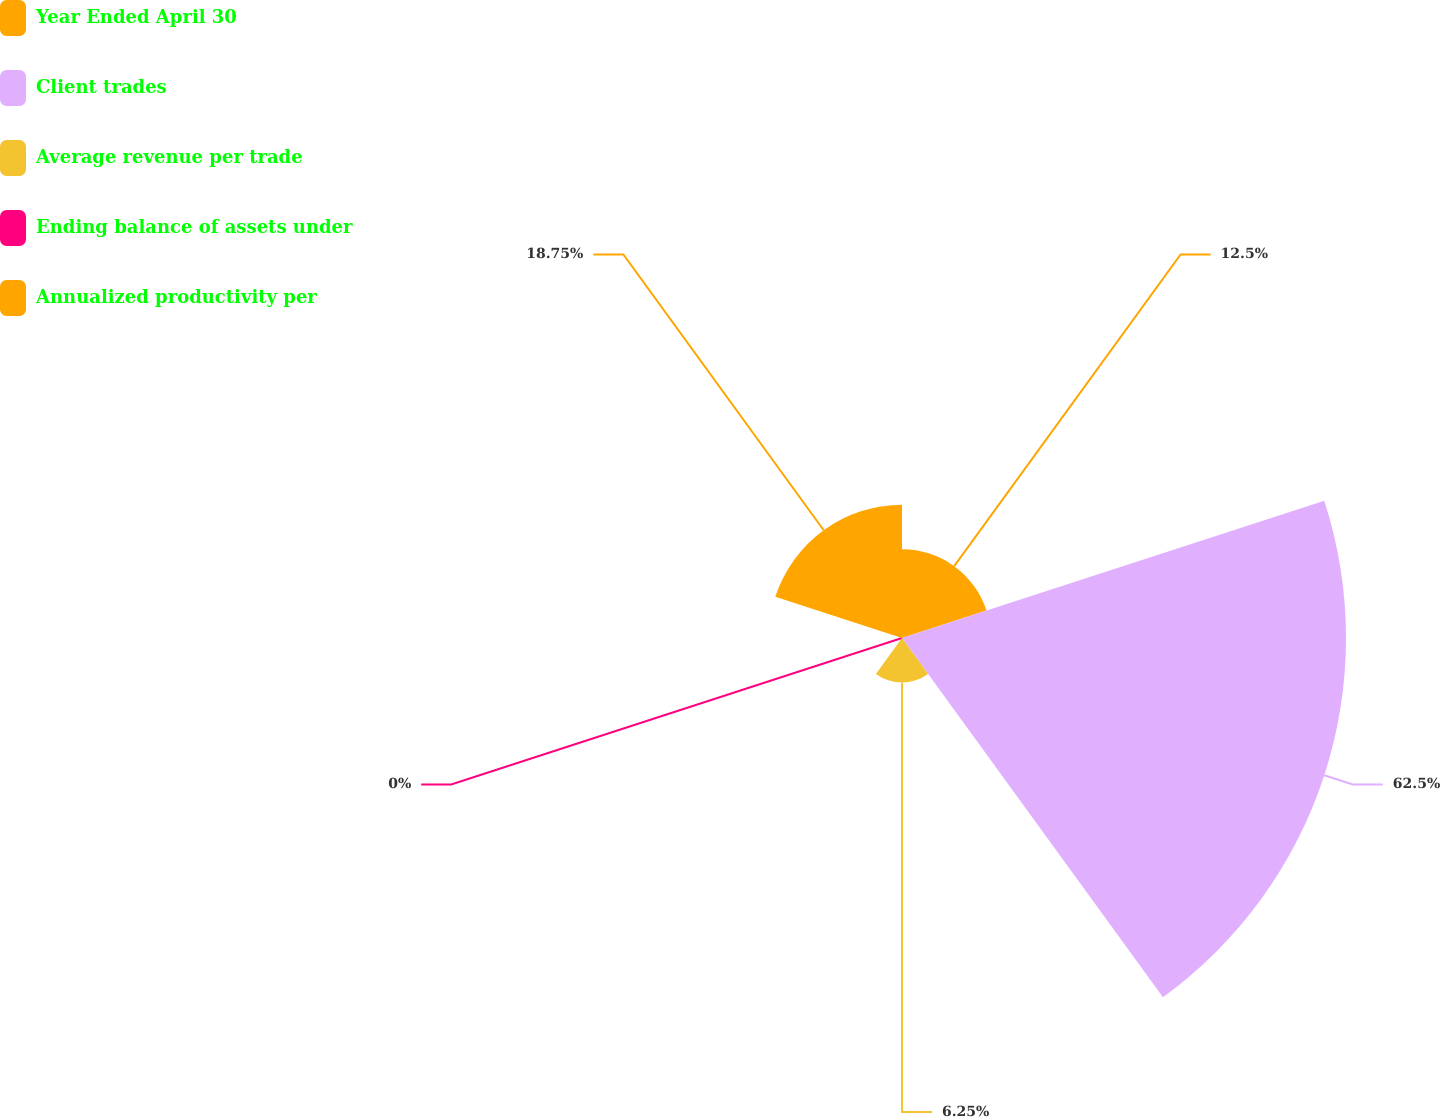<chart> <loc_0><loc_0><loc_500><loc_500><pie_chart><fcel>Year Ended April 30<fcel>Client trades<fcel>Average revenue per trade<fcel>Ending balance of assets under<fcel>Annualized productivity per<nl><fcel>12.5%<fcel>62.5%<fcel>6.25%<fcel>0.0%<fcel>18.75%<nl></chart> 